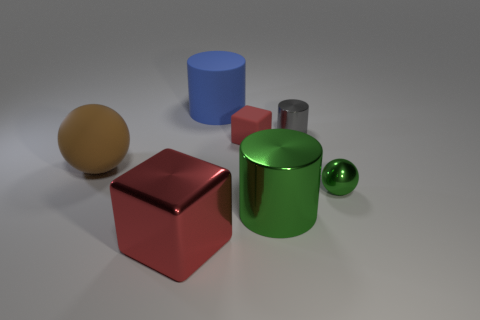There is a red block that is the same size as the gray metal thing; what is its material?
Give a very brief answer. Rubber. Does the green cylinder have the same size as the blue thing that is behind the tiny red object?
Give a very brief answer. Yes. What is the material of the cylinder in front of the tiny red matte cube?
Make the answer very short. Metal. Is the number of gray metallic things in front of the large green metal object the same as the number of tiny yellow matte cylinders?
Your answer should be very brief. Yes. Do the green sphere and the gray metal cylinder have the same size?
Your response must be concise. Yes. Are there any red rubber things behind the small cylinder that is on the right side of the shiny cylinder that is in front of the brown rubber object?
Give a very brief answer. No. What material is the blue object that is the same shape as the gray metallic object?
Offer a terse response. Rubber. How many small green objects are on the left side of the cube behind the large cube?
Offer a terse response. 0. There is a metallic thing behind the rubber thing that is on the left side of the big shiny thing that is in front of the big metallic cylinder; how big is it?
Keep it short and to the point. Small. The cube right of the cylinder that is left of the large green shiny object is what color?
Offer a very short reply. Red. 